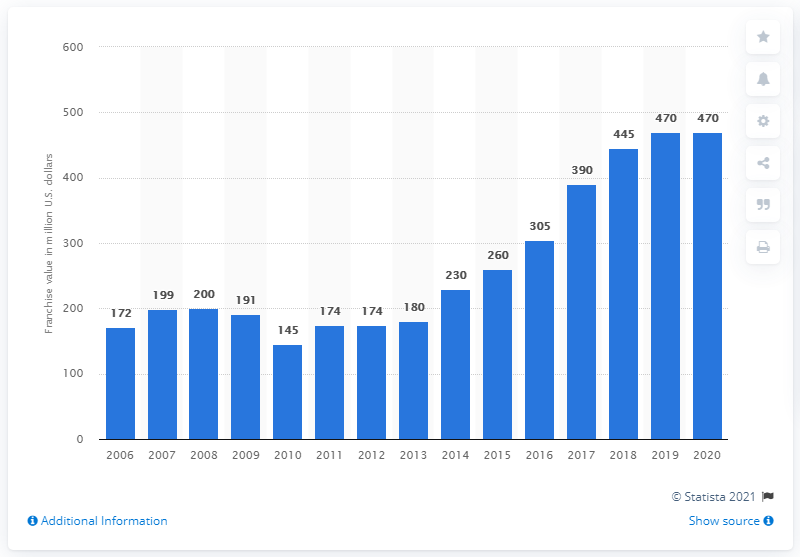Indicate a few pertinent items in this graphic. In the year 2020, the value of the Tampa Bay Lightning franchise was estimated to be 470 million dollars. 